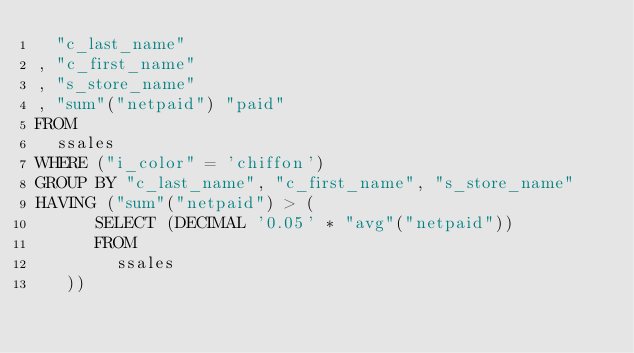<code> <loc_0><loc_0><loc_500><loc_500><_SQL_>  "c_last_name"
, "c_first_name"
, "s_store_name"
, "sum"("netpaid") "paid"
FROM
  ssales
WHERE ("i_color" = 'chiffon')
GROUP BY "c_last_name", "c_first_name", "s_store_name"
HAVING ("sum"("netpaid") > (
      SELECT (DECIMAL '0.05' * "avg"("netpaid"))
      FROM
        ssales
   ))
</code> 